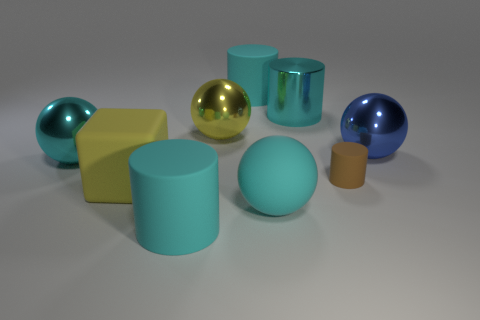There is a big sphere on the right side of the cyan shiny cylinder; does it have the same color as the metal cylinder?
Provide a succinct answer. No. How many other things are there of the same color as the matte block?
Make the answer very short. 1. Is the color of the rubber cube the same as the big matte ball?
Keep it short and to the point. No. How many large cyan objects are to the right of the yellow cube and behind the tiny brown cylinder?
Your answer should be compact. 2. What number of large objects are on the left side of the large yellow shiny ball?
Make the answer very short. 3. Is there a big cyan shiny object of the same shape as the tiny thing?
Give a very brief answer. Yes. Is the shape of the blue metallic thing the same as the cyan metal thing to the left of the metallic cylinder?
Your response must be concise. Yes. How many cylinders are either blue shiny things or brown rubber things?
Your response must be concise. 1. What shape is the large cyan rubber object behind the big cyan metallic cylinder?
Provide a short and direct response. Cylinder. How many small cylinders have the same material as the large yellow block?
Provide a succinct answer. 1. 